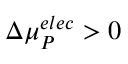<formula> <loc_0><loc_0><loc_500><loc_500>\Delta { \mu } _ { P } ^ { e l e c } > 0</formula> 